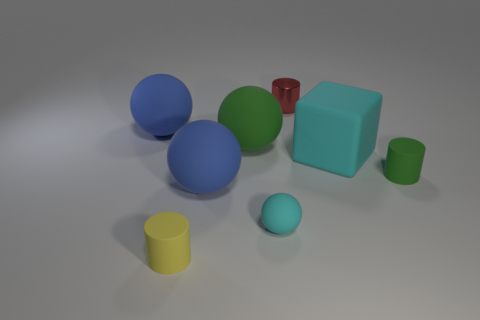Add 2 small yellow things. How many objects exist? 10 Subtract all green cylinders. How many cylinders are left? 2 Subtract all green matte balls. How many balls are left? 3 Subtract all cubes. How many objects are left? 7 Add 1 tiny metallic cylinders. How many tiny metallic cylinders exist? 2 Subtract 1 yellow cylinders. How many objects are left? 7 Subtract 1 cylinders. How many cylinders are left? 2 Subtract all yellow spheres. Subtract all gray cubes. How many spheres are left? 4 Subtract all green spheres. How many green cylinders are left? 1 Subtract all large green rubber cylinders. Subtract all cyan cubes. How many objects are left? 7 